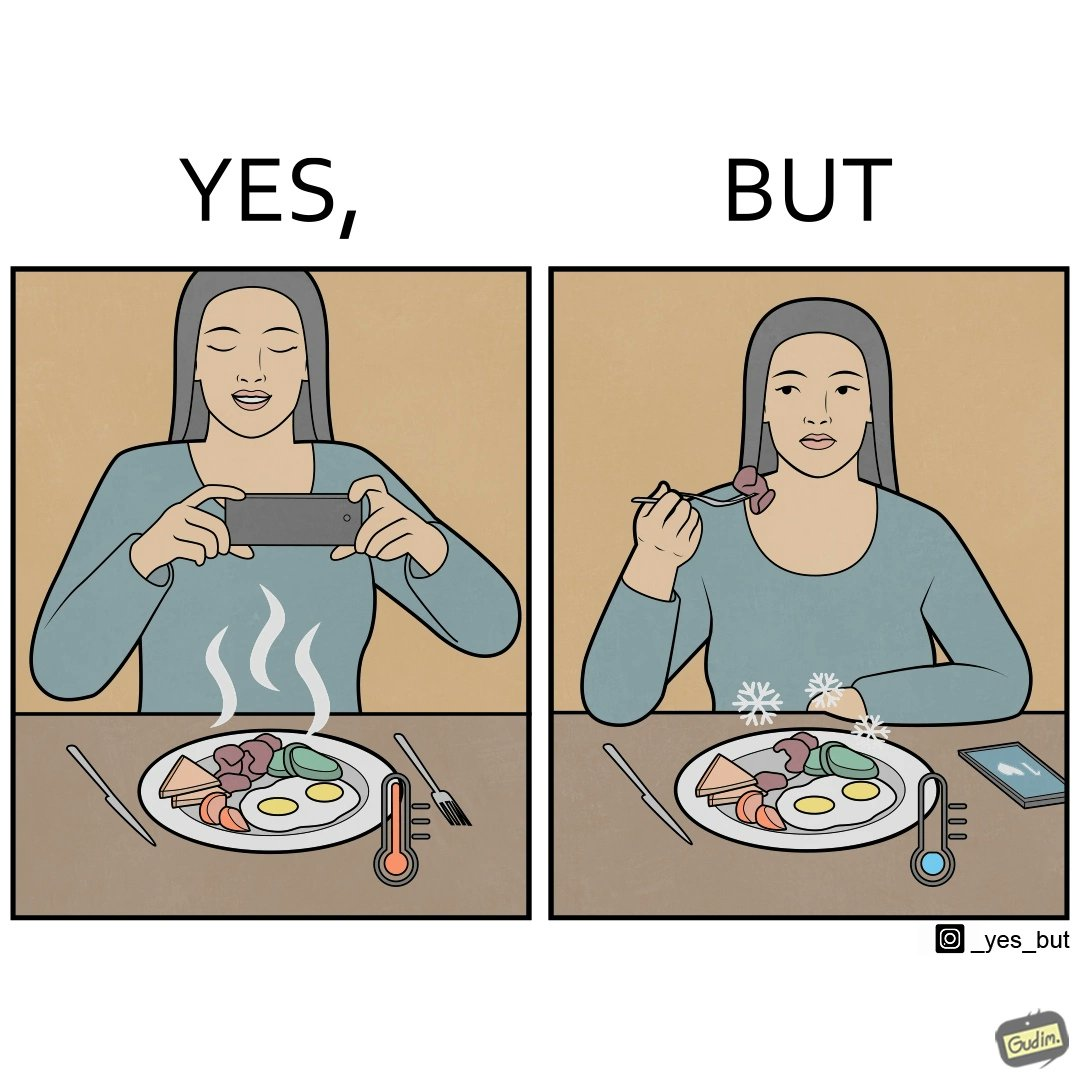Describe the content of this image. The images are funny since they show how a woman chooses to spend time clicking pictures of her food and by the time she is done, the food is already cold and not as appetizing as it was 